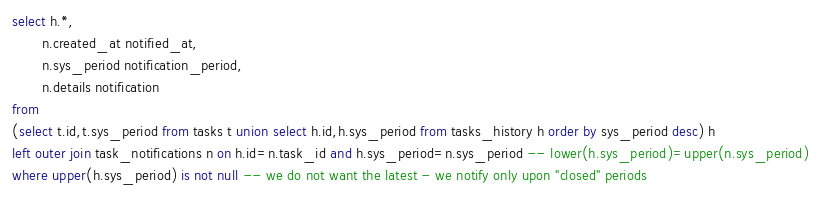Convert code to text. <code><loc_0><loc_0><loc_500><loc_500><_SQL_>select h.*,
       n.created_at notified_at,
       n.sys_period notification_period,
       n.details notification
from
(select t.id,t.sys_period from tasks t union select h.id,h.sys_period from tasks_history h order by sys_period desc) h
left outer join task_notifications n on h.id=n.task_id and h.sys_period=n.sys_period -- lower(h.sys_period)=upper(n.sys_period)
where upper(h.sys_period) is not null -- we do not want the latest - we notify only upon "closed" periods

</code> 